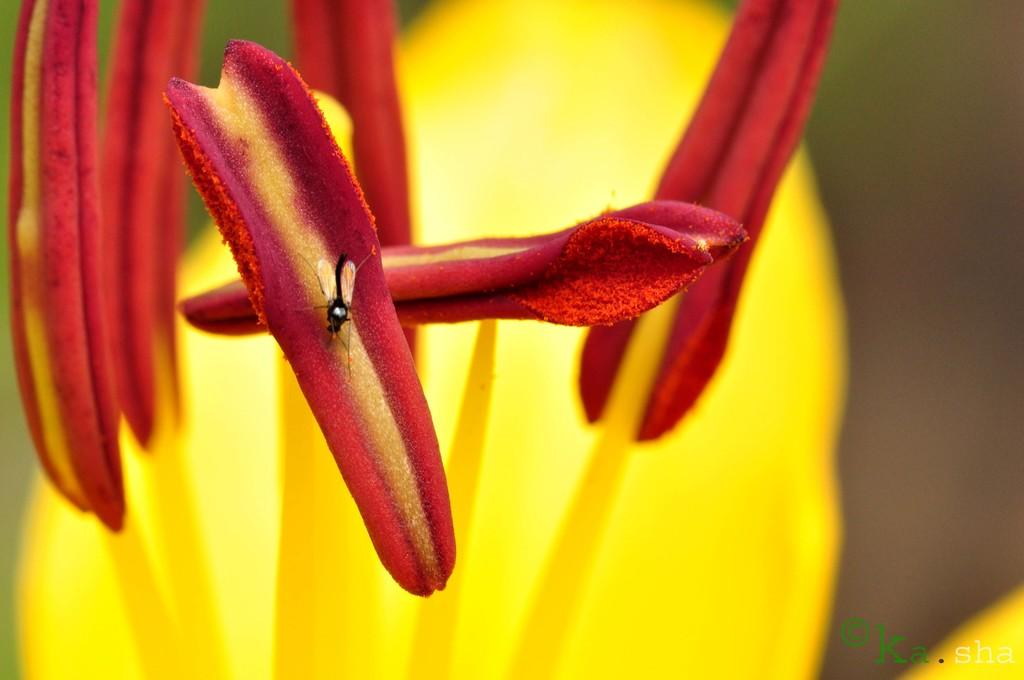What is present in the image? There is a fly in the image. What is the fly doing or located on? The fly is on a pollen grain. What can be observed about the background of the image? The background of the image is colored. What type of sweater is the fly wearing in the image? There is no sweater present in the image, as flies do not wear clothing. 